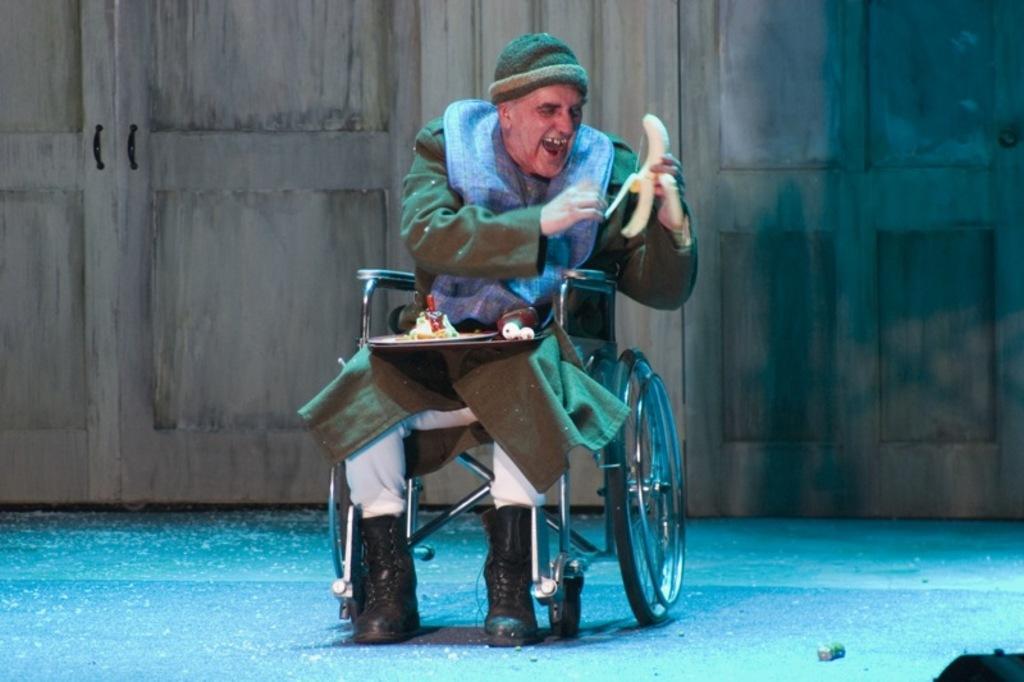Could you give a brief overview of what you see in this image? As we can see in the image there is a man holding banana and sitting on wheelchair. In the background there are wooden doors. 